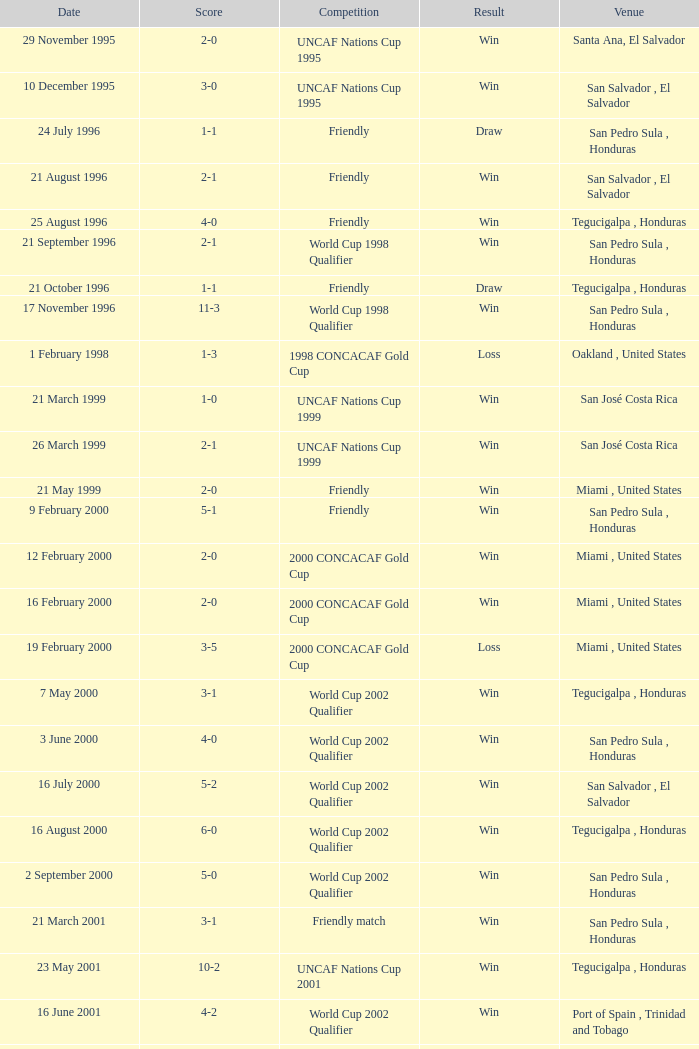Name the score for 7 may 2000 3-1. 